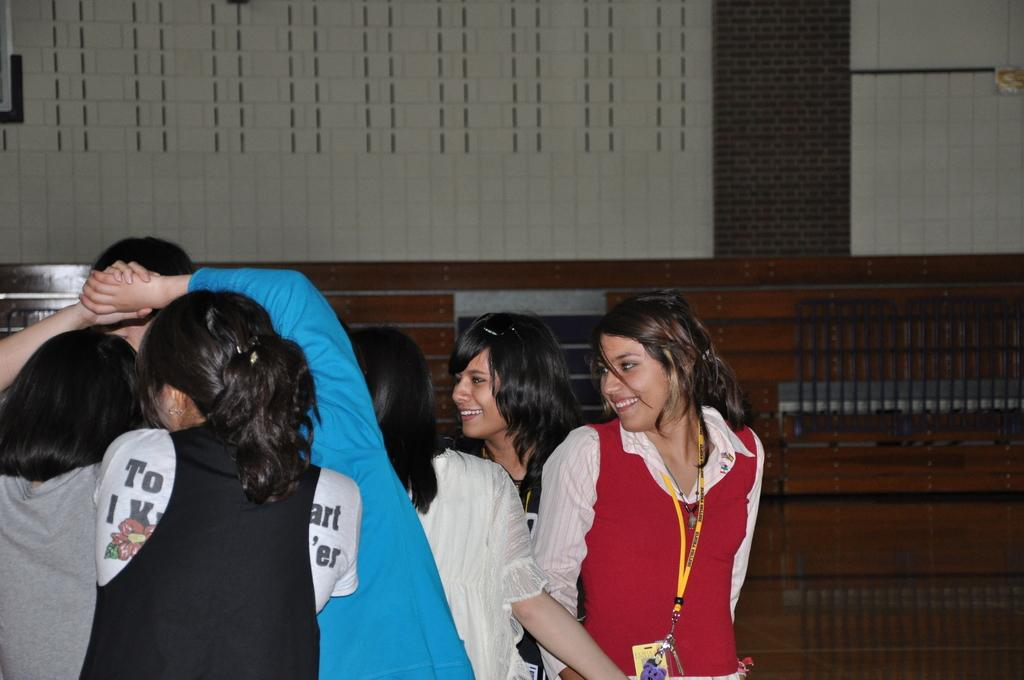Who or what is present in the image? There are people in the image. Where are the people located in the image? The people are at the bottom of the image. What can be seen in the background of the image? There is a wall in the background of the image. What type of company is mentioned in the image? There is no mention of a company in the image. Is there any payment being made in the image? There is no indication of any payment being made in the image. 